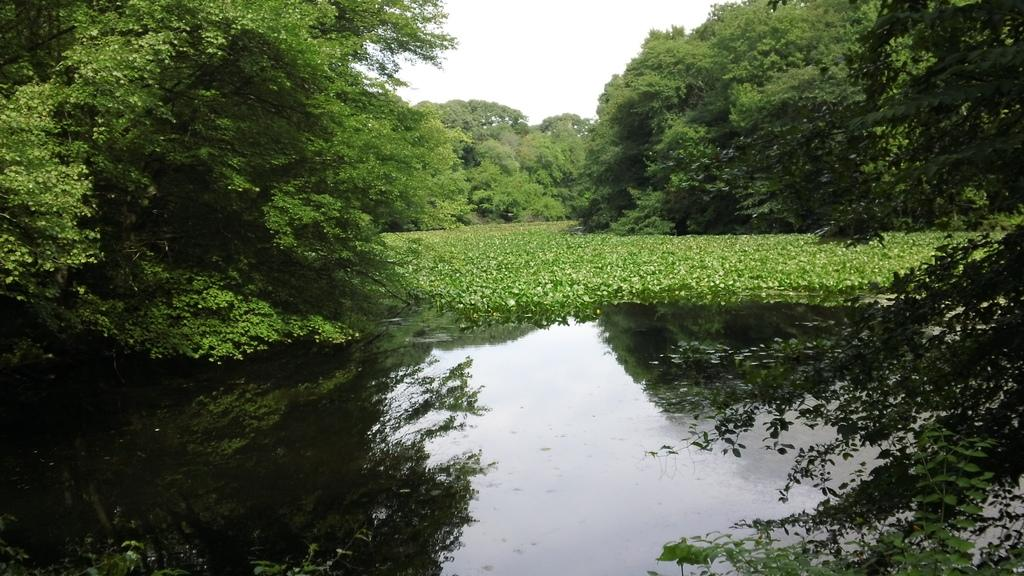What type of vegetation can be seen in the image? There are plants and trees in the image. What is visible in the water in the image? There are reflections on the water in the image. What can be seen in the background of the image? The sky is visible in the background of the image. How can you describe the water in the image? The water is visible and has reflections on its surface. What type of payment is required to enter the quiet area in the image? There is no mention of a quiet area or payment in the image; it features plants, trees, water, and a sky background. 